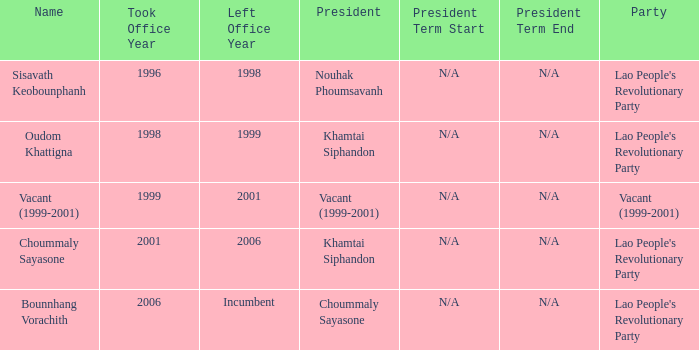What is Left Office, when Took Office is 2006? Incumbent. 